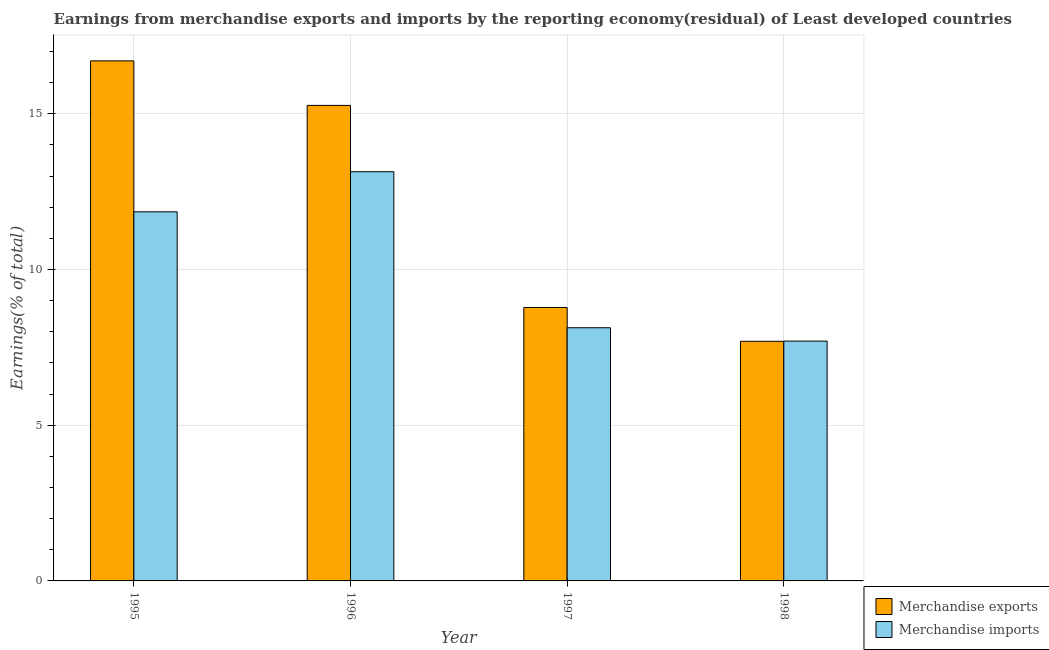Are the number of bars on each tick of the X-axis equal?
Ensure brevity in your answer.  Yes. How many bars are there on the 4th tick from the left?
Your response must be concise. 2. What is the label of the 4th group of bars from the left?
Keep it short and to the point. 1998. In how many cases, is the number of bars for a given year not equal to the number of legend labels?
Give a very brief answer. 0. What is the earnings from merchandise imports in 1998?
Keep it short and to the point. 7.7. Across all years, what is the maximum earnings from merchandise exports?
Keep it short and to the point. 16.7. Across all years, what is the minimum earnings from merchandise imports?
Provide a succinct answer. 7.7. In which year was the earnings from merchandise imports maximum?
Provide a succinct answer. 1996. What is the total earnings from merchandise imports in the graph?
Your answer should be compact. 40.82. What is the difference between the earnings from merchandise exports in 1995 and that in 1996?
Offer a terse response. 1.43. What is the difference between the earnings from merchandise imports in 1997 and the earnings from merchandise exports in 1998?
Provide a short and direct response. 0.43. What is the average earnings from merchandise imports per year?
Keep it short and to the point. 10.2. In how many years, is the earnings from merchandise exports greater than 6 %?
Offer a terse response. 4. What is the ratio of the earnings from merchandise exports in 1995 to that in 1996?
Provide a succinct answer. 1.09. What is the difference between the highest and the second highest earnings from merchandise exports?
Make the answer very short. 1.43. What is the difference between the highest and the lowest earnings from merchandise exports?
Your answer should be compact. 9. In how many years, is the earnings from merchandise exports greater than the average earnings from merchandise exports taken over all years?
Your answer should be very brief. 2. Is the sum of the earnings from merchandise imports in 1995 and 1997 greater than the maximum earnings from merchandise exports across all years?
Provide a succinct answer. Yes. What does the 2nd bar from the right in 1997 represents?
Offer a terse response. Merchandise exports. Are all the bars in the graph horizontal?
Offer a terse response. No. What is the difference between two consecutive major ticks on the Y-axis?
Offer a terse response. 5. Does the graph contain any zero values?
Ensure brevity in your answer.  No. Where does the legend appear in the graph?
Offer a terse response. Bottom right. What is the title of the graph?
Provide a short and direct response. Earnings from merchandise exports and imports by the reporting economy(residual) of Least developed countries. Does "current US$" appear as one of the legend labels in the graph?
Provide a short and direct response. No. What is the label or title of the Y-axis?
Make the answer very short. Earnings(% of total). What is the Earnings(% of total) in Merchandise exports in 1995?
Offer a terse response. 16.7. What is the Earnings(% of total) in Merchandise imports in 1995?
Keep it short and to the point. 11.85. What is the Earnings(% of total) of Merchandise exports in 1996?
Provide a short and direct response. 15.27. What is the Earnings(% of total) of Merchandise imports in 1996?
Give a very brief answer. 13.14. What is the Earnings(% of total) in Merchandise exports in 1997?
Keep it short and to the point. 8.78. What is the Earnings(% of total) of Merchandise imports in 1997?
Offer a very short reply. 8.13. What is the Earnings(% of total) of Merchandise exports in 1998?
Provide a succinct answer. 7.69. What is the Earnings(% of total) of Merchandise imports in 1998?
Give a very brief answer. 7.7. Across all years, what is the maximum Earnings(% of total) of Merchandise exports?
Your response must be concise. 16.7. Across all years, what is the maximum Earnings(% of total) in Merchandise imports?
Offer a terse response. 13.14. Across all years, what is the minimum Earnings(% of total) of Merchandise exports?
Provide a succinct answer. 7.69. Across all years, what is the minimum Earnings(% of total) of Merchandise imports?
Make the answer very short. 7.7. What is the total Earnings(% of total) of Merchandise exports in the graph?
Offer a very short reply. 48.44. What is the total Earnings(% of total) of Merchandise imports in the graph?
Give a very brief answer. 40.82. What is the difference between the Earnings(% of total) of Merchandise exports in 1995 and that in 1996?
Offer a terse response. 1.43. What is the difference between the Earnings(% of total) in Merchandise imports in 1995 and that in 1996?
Give a very brief answer. -1.29. What is the difference between the Earnings(% of total) in Merchandise exports in 1995 and that in 1997?
Make the answer very short. 7.92. What is the difference between the Earnings(% of total) in Merchandise imports in 1995 and that in 1997?
Keep it short and to the point. 3.72. What is the difference between the Earnings(% of total) of Merchandise exports in 1995 and that in 1998?
Keep it short and to the point. 9. What is the difference between the Earnings(% of total) in Merchandise imports in 1995 and that in 1998?
Offer a terse response. 4.15. What is the difference between the Earnings(% of total) of Merchandise exports in 1996 and that in 1997?
Make the answer very short. 6.49. What is the difference between the Earnings(% of total) of Merchandise imports in 1996 and that in 1997?
Offer a very short reply. 5.01. What is the difference between the Earnings(% of total) of Merchandise exports in 1996 and that in 1998?
Provide a succinct answer. 7.57. What is the difference between the Earnings(% of total) of Merchandise imports in 1996 and that in 1998?
Your answer should be compact. 5.44. What is the difference between the Earnings(% of total) of Merchandise exports in 1997 and that in 1998?
Offer a terse response. 1.08. What is the difference between the Earnings(% of total) in Merchandise imports in 1997 and that in 1998?
Make the answer very short. 0.43. What is the difference between the Earnings(% of total) of Merchandise exports in 1995 and the Earnings(% of total) of Merchandise imports in 1996?
Provide a succinct answer. 3.56. What is the difference between the Earnings(% of total) of Merchandise exports in 1995 and the Earnings(% of total) of Merchandise imports in 1997?
Keep it short and to the point. 8.57. What is the difference between the Earnings(% of total) of Merchandise exports in 1995 and the Earnings(% of total) of Merchandise imports in 1998?
Provide a short and direct response. 9. What is the difference between the Earnings(% of total) of Merchandise exports in 1996 and the Earnings(% of total) of Merchandise imports in 1997?
Your response must be concise. 7.14. What is the difference between the Earnings(% of total) in Merchandise exports in 1996 and the Earnings(% of total) in Merchandise imports in 1998?
Offer a very short reply. 7.57. What is the difference between the Earnings(% of total) in Merchandise exports in 1997 and the Earnings(% of total) in Merchandise imports in 1998?
Offer a very short reply. 1.08. What is the average Earnings(% of total) in Merchandise exports per year?
Provide a succinct answer. 12.11. What is the average Earnings(% of total) in Merchandise imports per year?
Provide a short and direct response. 10.2. In the year 1995, what is the difference between the Earnings(% of total) in Merchandise exports and Earnings(% of total) in Merchandise imports?
Ensure brevity in your answer.  4.85. In the year 1996, what is the difference between the Earnings(% of total) in Merchandise exports and Earnings(% of total) in Merchandise imports?
Keep it short and to the point. 2.13. In the year 1997, what is the difference between the Earnings(% of total) of Merchandise exports and Earnings(% of total) of Merchandise imports?
Your response must be concise. 0.65. In the year 1998, what is the difference between the Earnings(% of total) of Merchandise exports and Earnings(% of total) of Merchandise imports?
Make the answer very short. -0.01. What is the ratio of the Earnings(% of total) in Merchandise exports in 1995 to that in 1996?
Your response must be concise. 1.09. What is the ratio of the Earnings(% of total) of Merchandise imports in 1995 to that in 1996?
Make the answer very short. 0.9. What is the ratio of the Earnings(% of total) in Merchandise exports in 1995 to that in 1997?
Your answer should be compact. 1.9. What is the ratio of the Earnings(% of total) of Merchandise imports in 1995 to that in 1997?
Provide a short and direct response. 1.46. What is the ratio of the Earnings(% of total) of Merchandise exports in 1995 to that in 1998?
Provide a succinct answer. 2.17. What is the ratio of the Earnings(% of total) in Merchandise imports in 1995 to that in 1998?
Ensure brevity in your answer.  1.54. What is the ratio of the Earnings(% of total) of Merchandise exports in 1996 to that in 1997?
Ensure brevity in your answer.  1.74. What is the ratio of the Earnings(% of total) of Merchandise imports in 1996 to that in 1997?
Make the answer very short. 1.62. What is the ratio of the Earnings(% of total) in Merchandise exports in 1996 to that in 1998?
Your response must be concise. 1.98. What is the ratio of the Earnings(% of total) in Merchandise imports in 1996 to that in 1998?
Provide a short and direct response. 1.71. What is the ratio of the Earnings(% of total) in Merchandise exports in 1997 to that in 1998?
Offer a terse response. 1.14. What is the ratio of the Earnings(% of total) in Merchandise imports in 1997 to that in 1998?
Your answer should be very brief. 1.06. What is the difference between the highest and the second highest Earnings(% of total) of Merchandise exports?
Ensure brevity in your answer.  1.43. What is the difference between the highest and the second highest Earnings(% of total) of Merchandise imports?
Make the answer very short. 1.29. What is the difference between the highest and the lowest Earnings(% of total) in Merchandise exports?
Your answer should be compact. 9. What is the difference between the highest and the lowest Earnings(% of total) in Merchandise imports?
Your answer should be very brief. 5.44. 